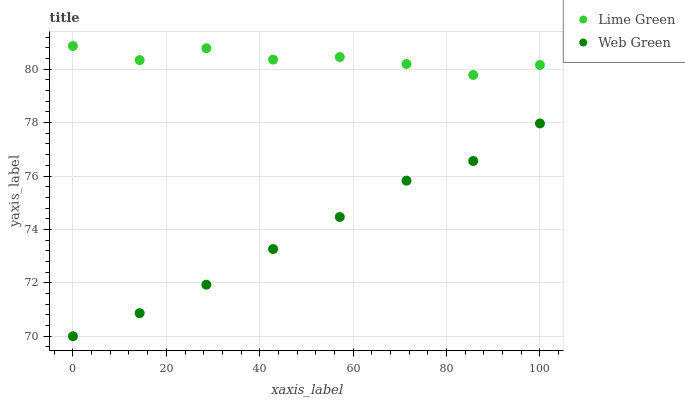Does Web Green have the minimum area under the curve?
Answer yes or no. Yes. Does Lime Green have the maximum area under the curve?
Answer yes or no. Yes. Does Web Green have the maximum area under the curve?
Answer yes or no. No. Is Web Green the smoothest?
Answer yes or no. Yes. Is Lime Green the roughest?
Answer yes or no. Yes. Is Web Green the roughest?
Answer yes or no. No. Does Web Green have the lowest value?
Answer yes or no. Yes. Does Lime Green have the highest value?
Answer yes or no. Yes. Does Web Green have the highest value?
Answer yes or no. No. Is Web Green less than Lime Green?
Answer yes or no. Yes. Is Lime Green greater than Web Green?
Answer yes or no. Yes. Does Web Green intersect Lime Green?
Answer yes or no. No. 